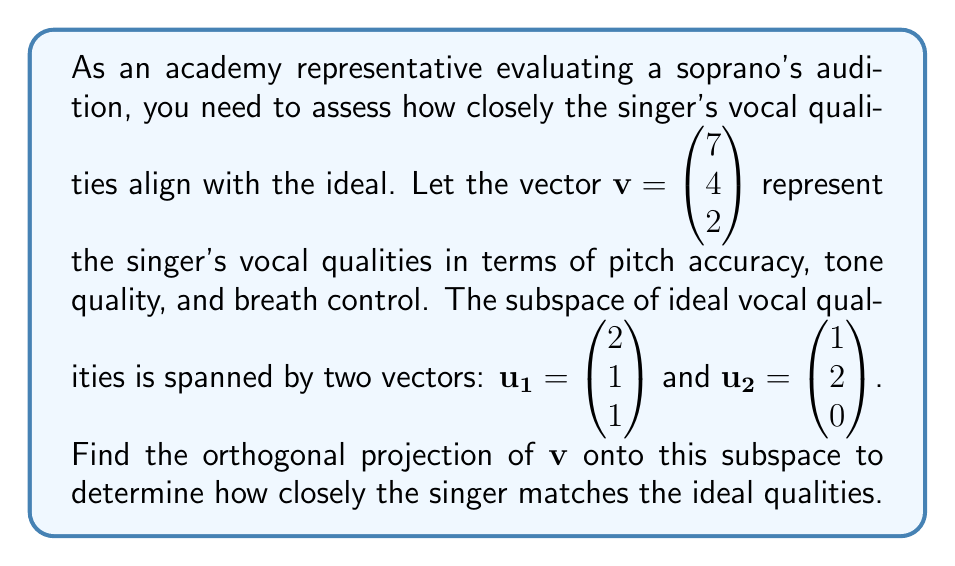Help me with this question. To find the orthogonal projection of $\mathbf{v}$ onto the subspace spanned by $\mathbf{u_1}$ and $\mathbf{u_2}$, we'll follow these steps:

1) First, we need to find an orthonormal basis for the subspace. We'll use the Gram-Schmidt process:

   $\mathbf{e_1} = \frac{\mathbf{u_1}}{\|\mathbf{u_1}\|} = \frac{1}{\sqrt{6}}\begin{pmatrix} 2 \\ 1 \\ 1 \end{pmatrix}$

   $\mathbf{u_2'} = \mathbf{u_2} - (\mathbf{u_2} \cdot \mathbf{e_1})\mathbf{e_1} = \begin{pmatrix} 1 \\ 2 \\ 0 \end{pmatrix} - \frac{4}{\sqrt{6}}\frac{1}{\sqrt{6}}\begin{pmatrix} 2 \\ 1 \\ 1 \end{pmatrix} = \begin{pmatrix} 1/3 \\ 5/3 \\ -2/3 \end{pmatrix}$

   $\mathbf{e_2} = \frac{\mathbf{u_2'}}{\|\mathbf{u_2'}\|} = \frac{1}{\sqrt{3}}\begin{pmatrix} 1/3 \\ 5/3 \\ -2/3 \end{pmatrix} = \frac{1}{3}\begin{pmatrix} 1 \\ 5 \\ -2 \end{pmatrix}$

2) Now, we can project $\mathbf{v}$ onto this orthonormal basis:

   $\text{proj}_W \mathbf{v} = (\mathbf{v} \cdot \mathbf{e_1})\mathbf{e_1} + (\mathbf{v} \cdot \mathbf{e_2})\mathbf{e_2}$

3) Calculate the dot products:

   $\mathbf{v} \cdot \mathbf{e_1} = \frac{1}{\sqrt{6}}(14 + 4 + 2) = \frac{20}{\sqrt{6}}$

   $\mathbf{v} \cdot \mathbf{e_2} = \frac{1}{3}(7 + 20 - 4) = \frac{23}{3}$

4) Substitute these values:

   $\text{proj}_W \mathbf{v} = \frac{20}{\sqrt{6}} \cdot \frac{1}{\sqrt{6}}\begin{pmatrix} 2 \\ 1 \\ 1 \end{pmatrix} + \frac{23}{3} \cdot \frac{1}{3}\begin{pmatrix} 1 \\ 5 \\ -2 \end{pmatrix}$

5) Simplify:

   $\text{proj}_W \mathbf{v} = \frac{20}{6}\begin{pmatrix} 2 \\ 1 \\ 1 \end{pmatrix} + \frac{23}{9}\begin{pmatrix} 1 \\ 5 \\ -2 \end{pmatrix}$

6) Calculate the final result:

   $\text{proj}_W \mathbf{v} = \begin{pmatrix} 20/3 + 23/9 \\ 10/3 + 115/9 \\ 10/3 - 46/9 \end{pmatrix} = \begin{pmatrix} 89/9 \\ 145/9 \\ 4/9 \end{pmatrix}$
Answer: The orthogonal projection of $\mathbf{v}$ onto the subspace is:

$$\text{proj}_W \mathbf{v} = \begin{pmatrix} 89/9 \\ 145/9 \\ 4/9 \end{pmatrix}$$ 